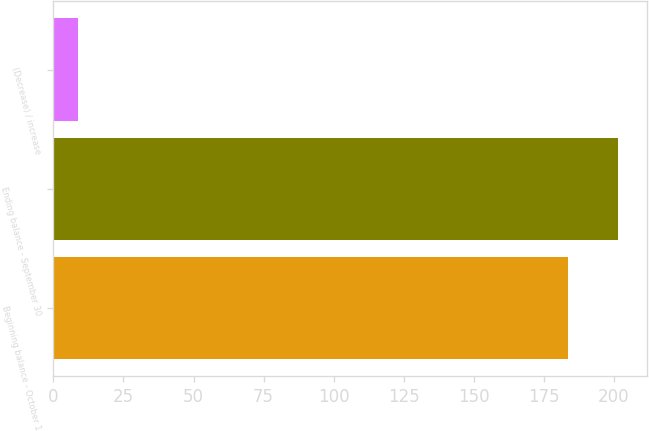<chart> <loc_0><loc_0><loc_500><loc_500><bar_chart><fcel>Beginning balance - October 1<fcel>Ending balance - September 30<fcel>(Decrease) / increase<nl><fcel>183.7<fcel>201.63<fcel>8.7<nl></chart> 